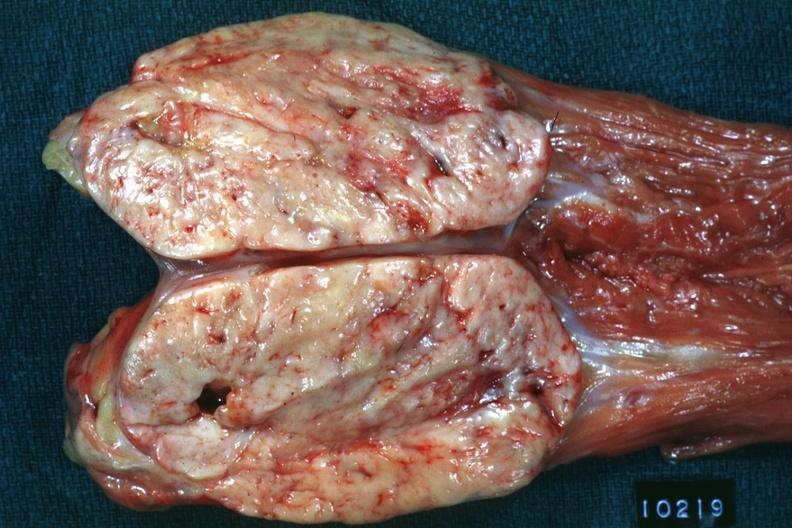s tuberculous peritonitis present?
Answer the question using a single word or phrase. No 